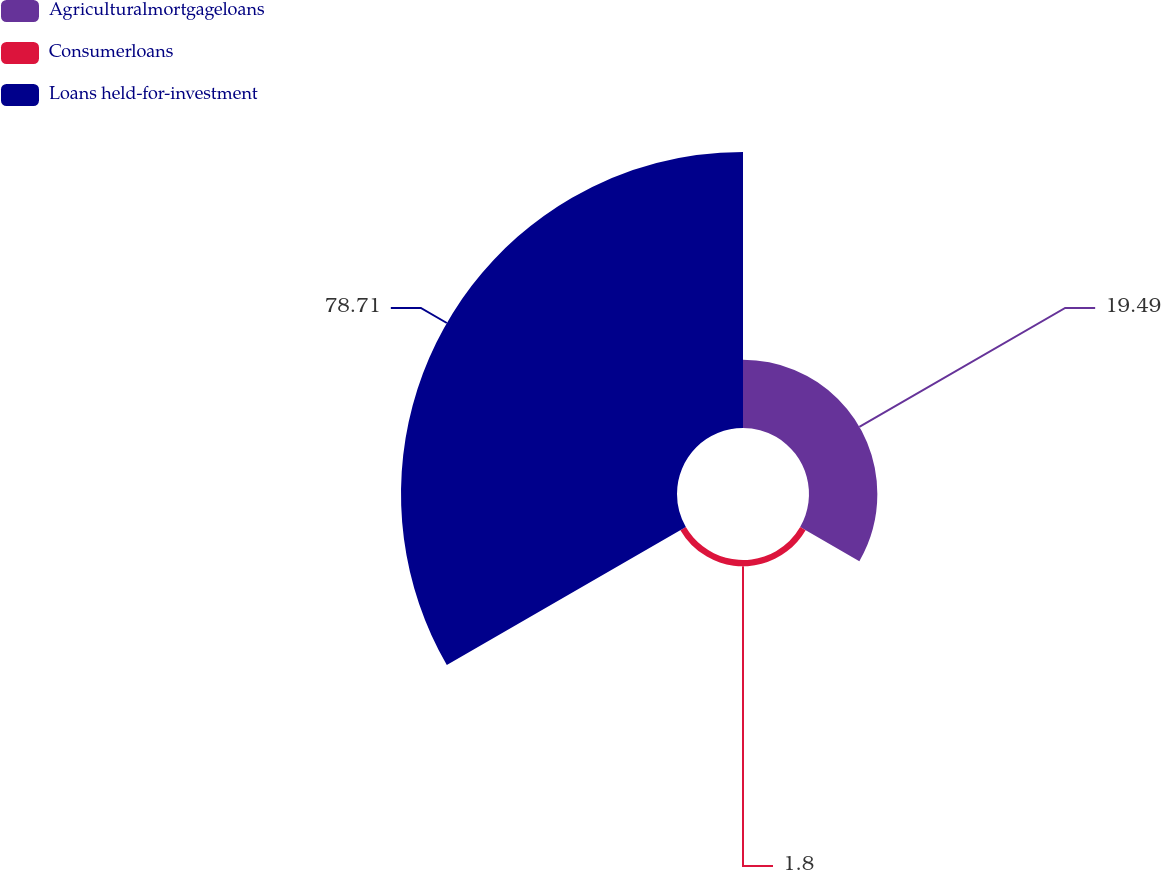Convert chart. <chart><loc_0><loc_0><loc_500><loc_500><pie_chart><fcel>Agriculturalmortgageloans<fcel>Consumerloans<fcel>Loans held-for-investment<nl><fcel>19.49%<fcel>1.8%<fcel>78.71%<nl></chart> 